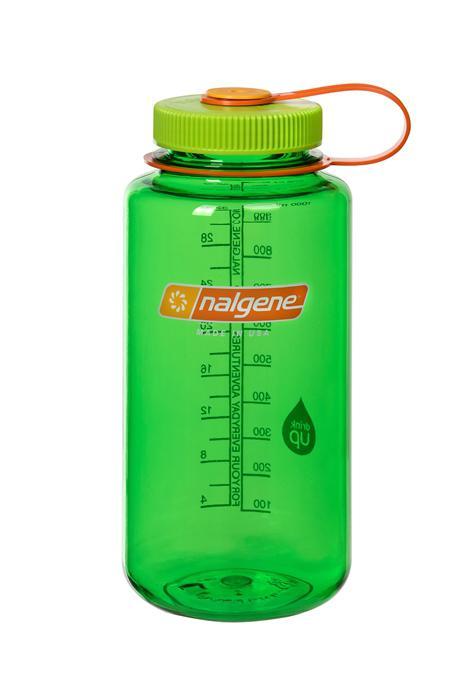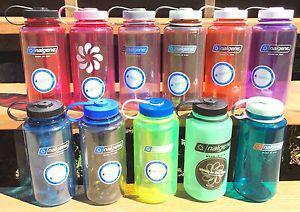The first image is the image on the left, the second image is the image on the right. Analyze the images presented: Is the assertion "The left and right image contains the same number of plastic bottles." valid? Answer yes or no. No. The first image is the image on the left, the second image is the image on the right. Analyze the images presented: Is the assertion "One image contains a single water bottle, and the other image contains at least seven water bottles." valid? Answer yes or no. Yes. 